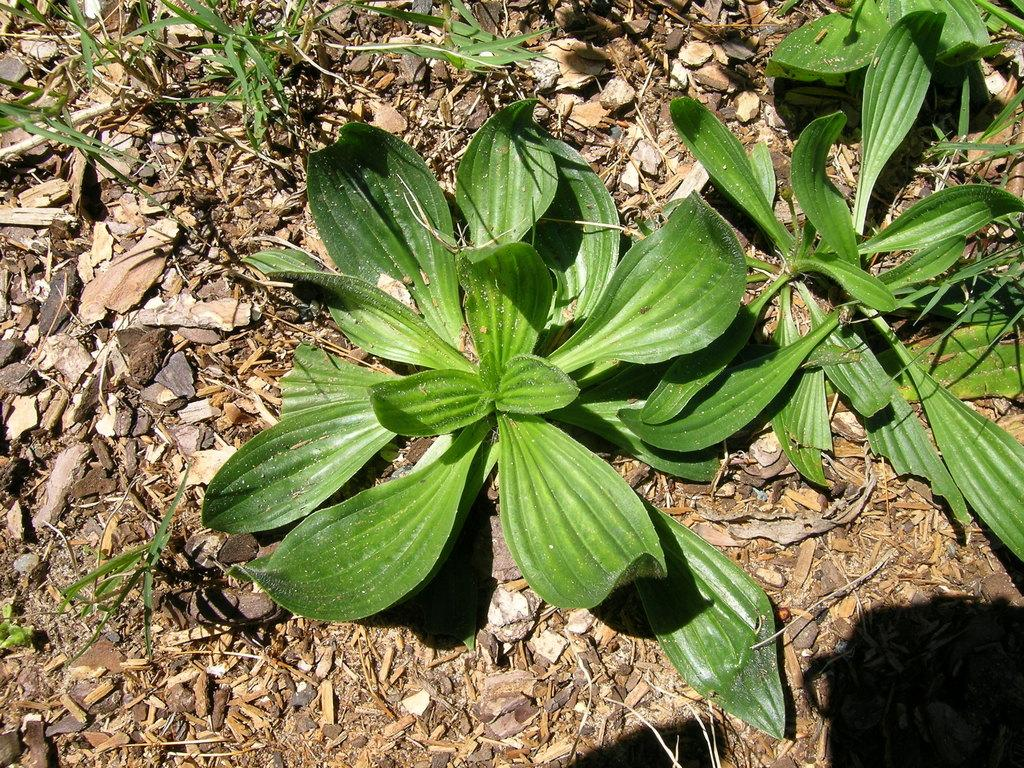What type of living organisms can be seen in the image? Plants can be seen in the image. What can be found on the surface of the plants in the image? There are leaves, dry leaves, branches, and stones on the surface in the image. What is the connection between the throat and the tongue in the image? There is no throat or tongue present in the image; it features plants with leaves, dry leaves, branches, and stones on their surfaces. 